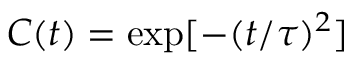Convert formula to latex. <formula><loc_0><loc_0><loc_500><loc_500>C ( t ) = e x p [ - ( t / \tau ) ^ { 2 } ]</formula> 